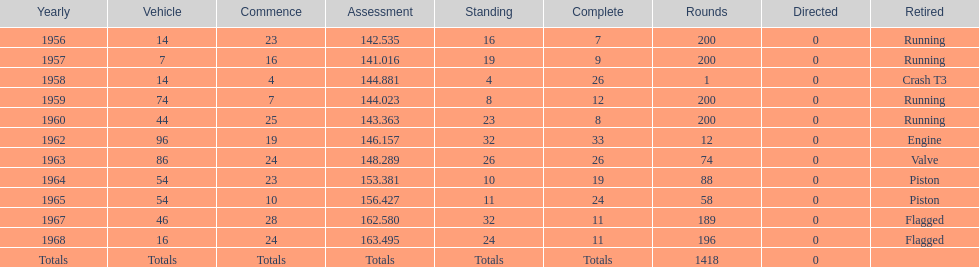How many times did he finish all 200 laps? 4. 